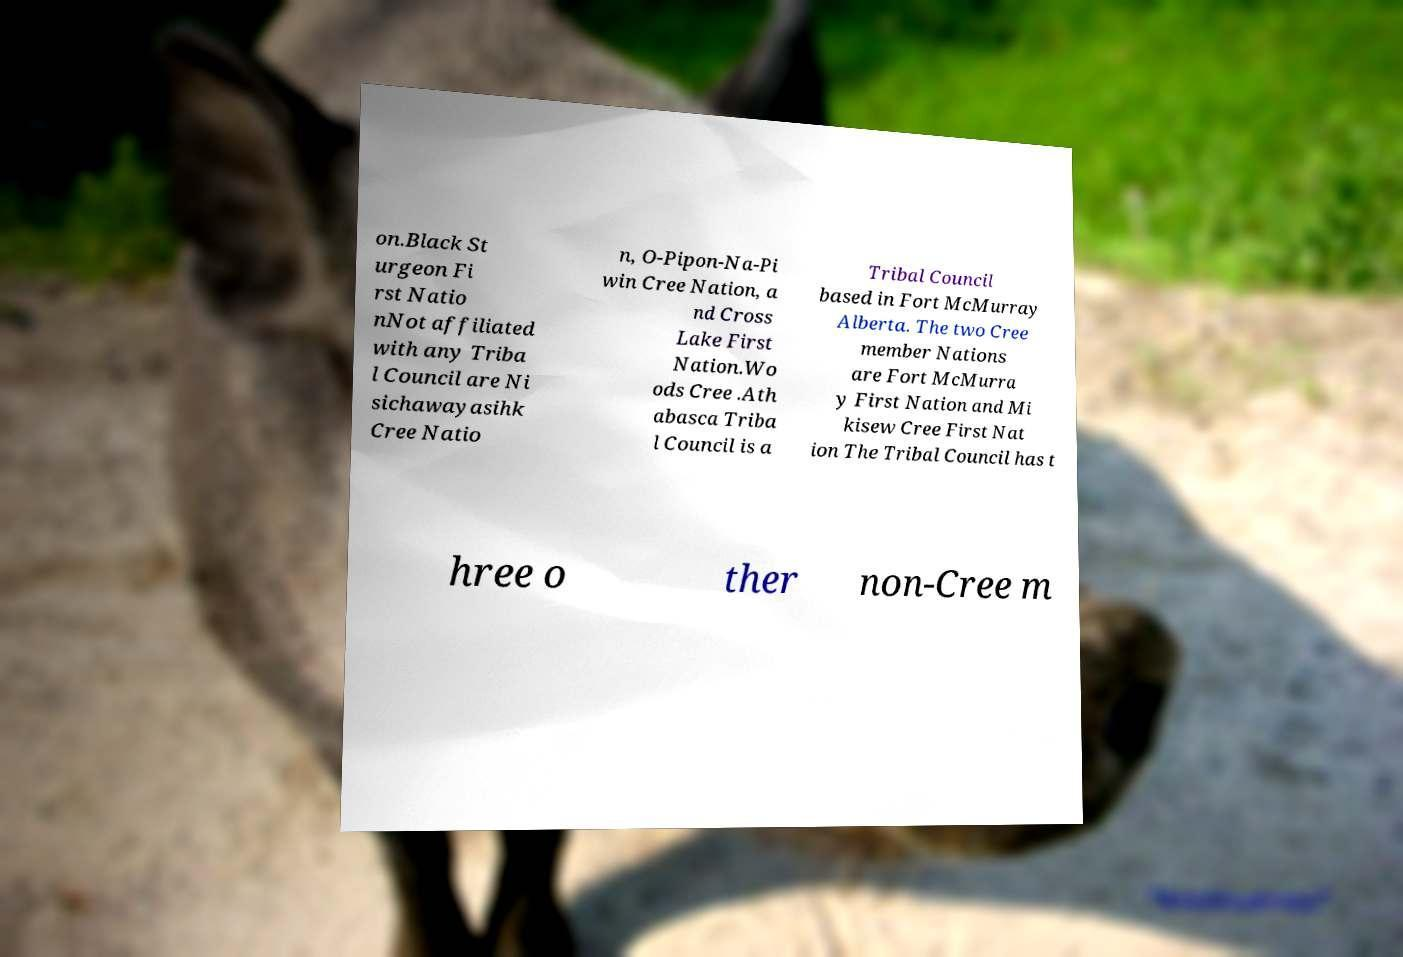Could you assist in decoding the text presented in this image and type it out clearly? on.Black St urgeon Fi rst Natio nNot affiliated with any Triba l Council are Ni sichawayasihk Cree Natio n, O-Pipon-Na-Pi win Cree Nation, a nd Cross Lake First Nation.Wo ods Cree .Ath abasca Triba l Council is a Tribal Council based in Fort McMurray Alberta. The two Cree member Nations are Fort McMurra y First Nation and Mi kisew Cree First Nat ion The Tribal Council has t hree o ther non-Cree m 